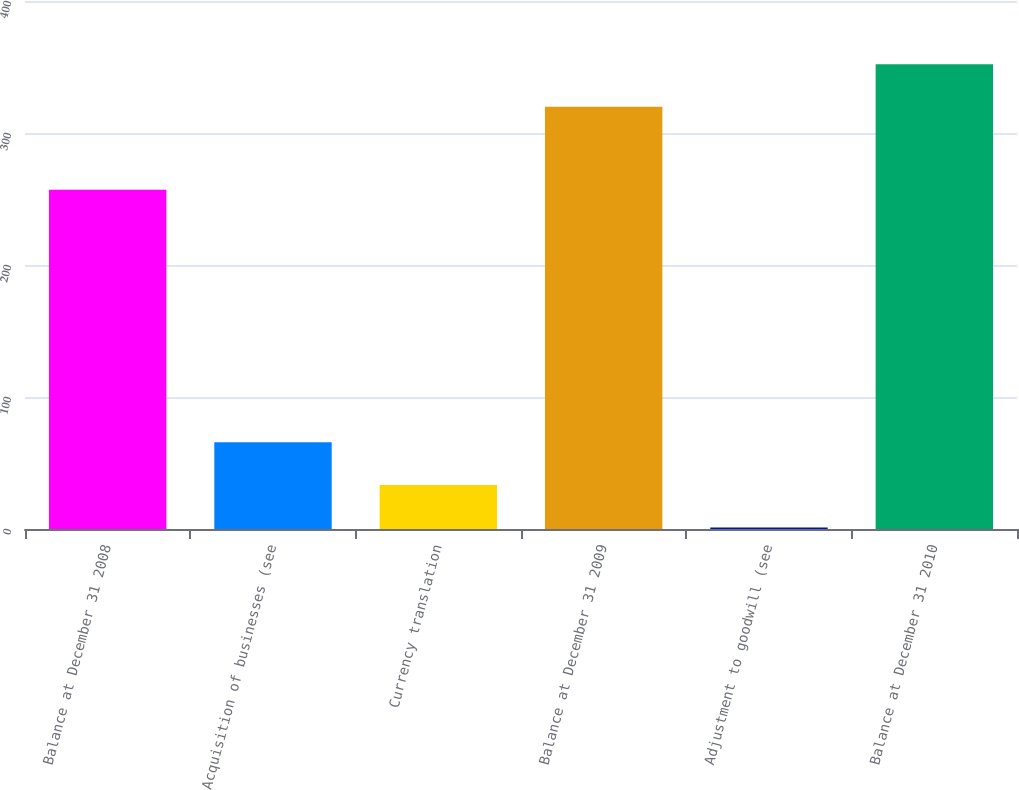<chart> <loc_0><loc_0><loc_500><loc_500><bar_chart><fcel>Balance at December 31 2008<fcel>Acquisition of businesses (see<fcel>Currency translation<fcel>Balance at December 31 2009<fcel>Adjustment to goodwill (see<fcel>Balance at December 31 2010<nl><fcel>257.1<fcel>65.64<fcel>33.37<fcel>319.9<fcel>1.1<fcel>352.17<nl></chart> 